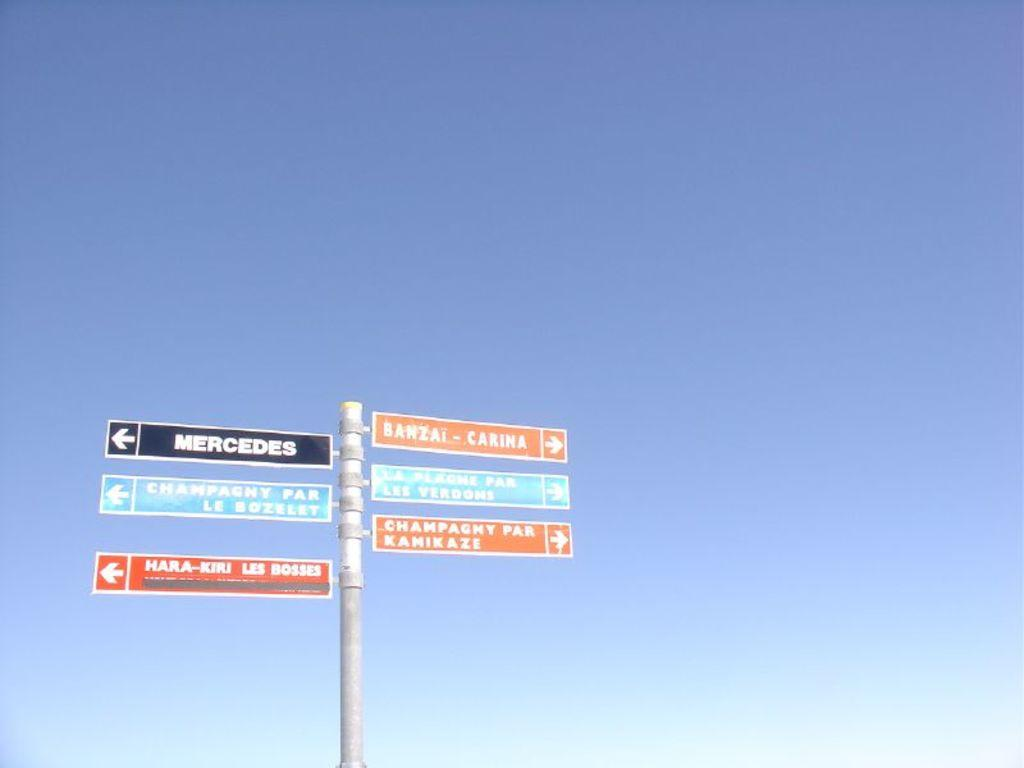<image>
Render a clear and concise summary of the photo. Six signs on a post, one pointing to Mercedes. 